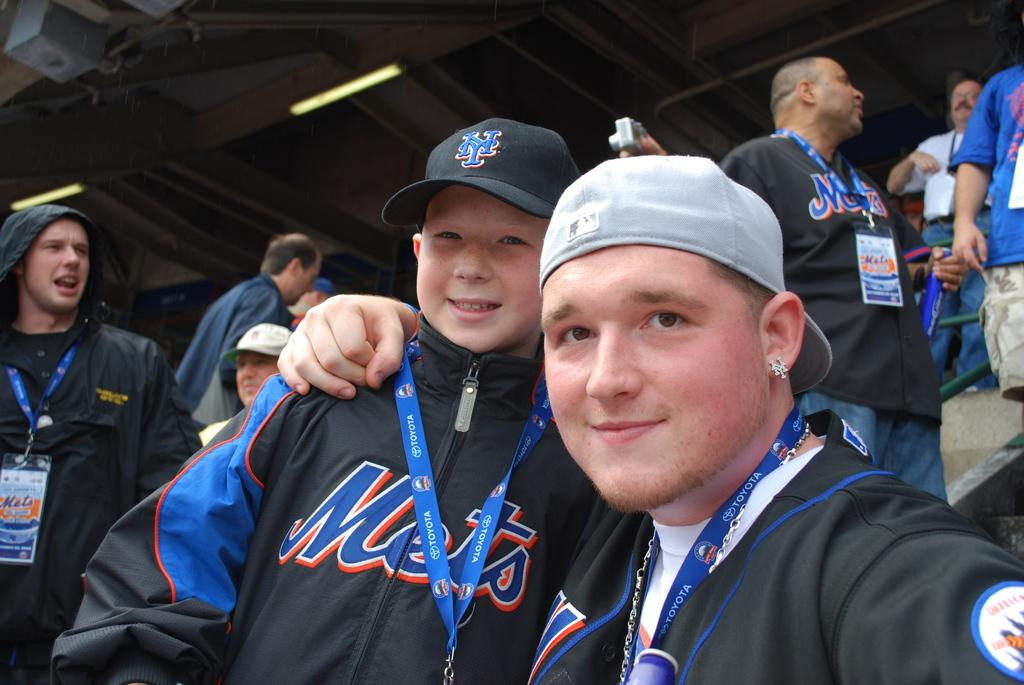Provide a one-sentence caption for the provided image. A man embraces a boy at a Mets sporting event. 